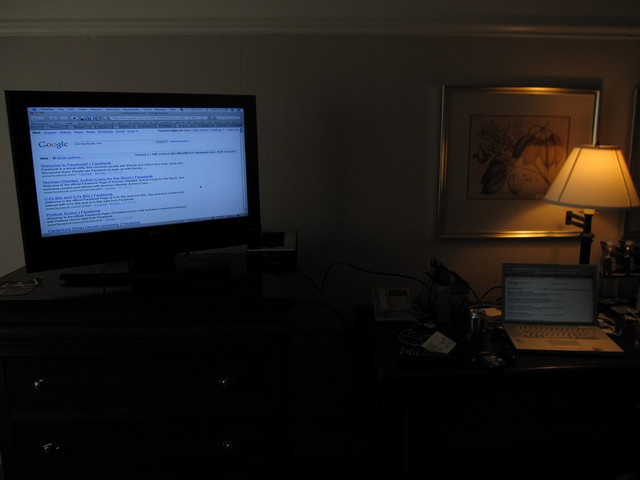Describe the objects in this image and their specific colors. I can see tv in black, gray, and blue tones and laptop in black and maroon tones in this image. 